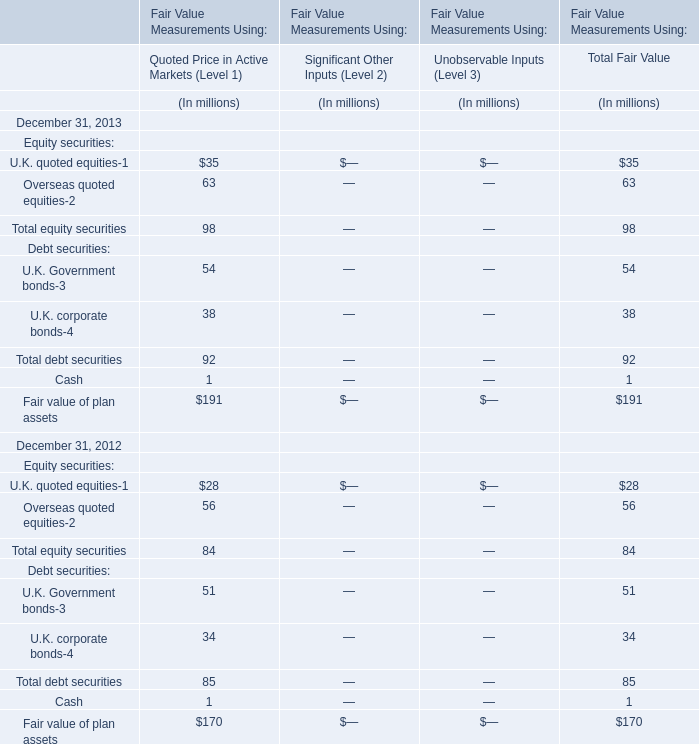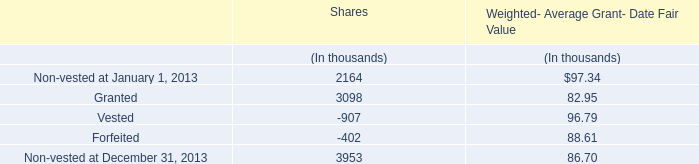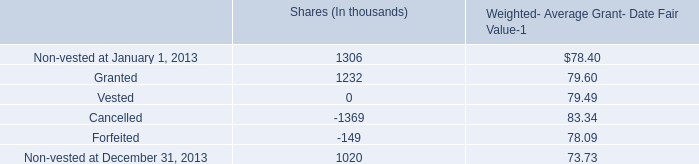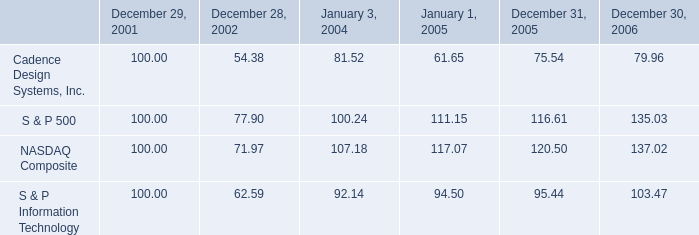If U.K. quoted equities in Quoted Price in Active Markets (Level 1) develops with the same growth rate in 2013, what will it reach in 2014? (in millions) 
Computations: ((1 + ((35 - 28) / 28)) * 35)
Answer: 43.75. 